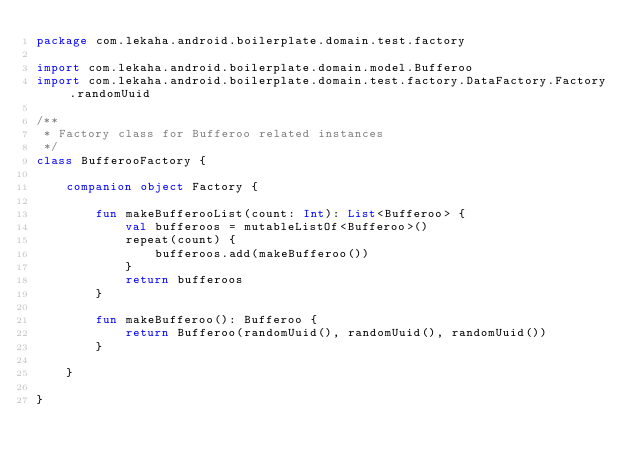Convert code to text. <code><loc_0><loc_0><loc_500><loc_500><_Kotlin_>package com.lekaha.android.boilerplate.domain.test.factory

import com.lekaha.android.boilerplate.domain.model.Bufferoo
import com.lekaha.android.boilerplate.domain.test.factory.DataFactory.Factory.randomUuid

/**
 * Factory class for Bufferoo related instances
 */
class BufferooFactory {

    companion object Factory {

        fun makeBufferooList(count: Int): List<Bufferoo> {
            val bufferoos = mutableListOf<Bufferoo>()
            repeat(count) {
                bufferoos.add(makeBufferoo())
            }
            return bufferoos
        }

        fun makeBufferoo(): Bufferoo {
            return Bufferoo(randomUuid(), randomUuid(), randomUuid())
        }

    }

}</code> 